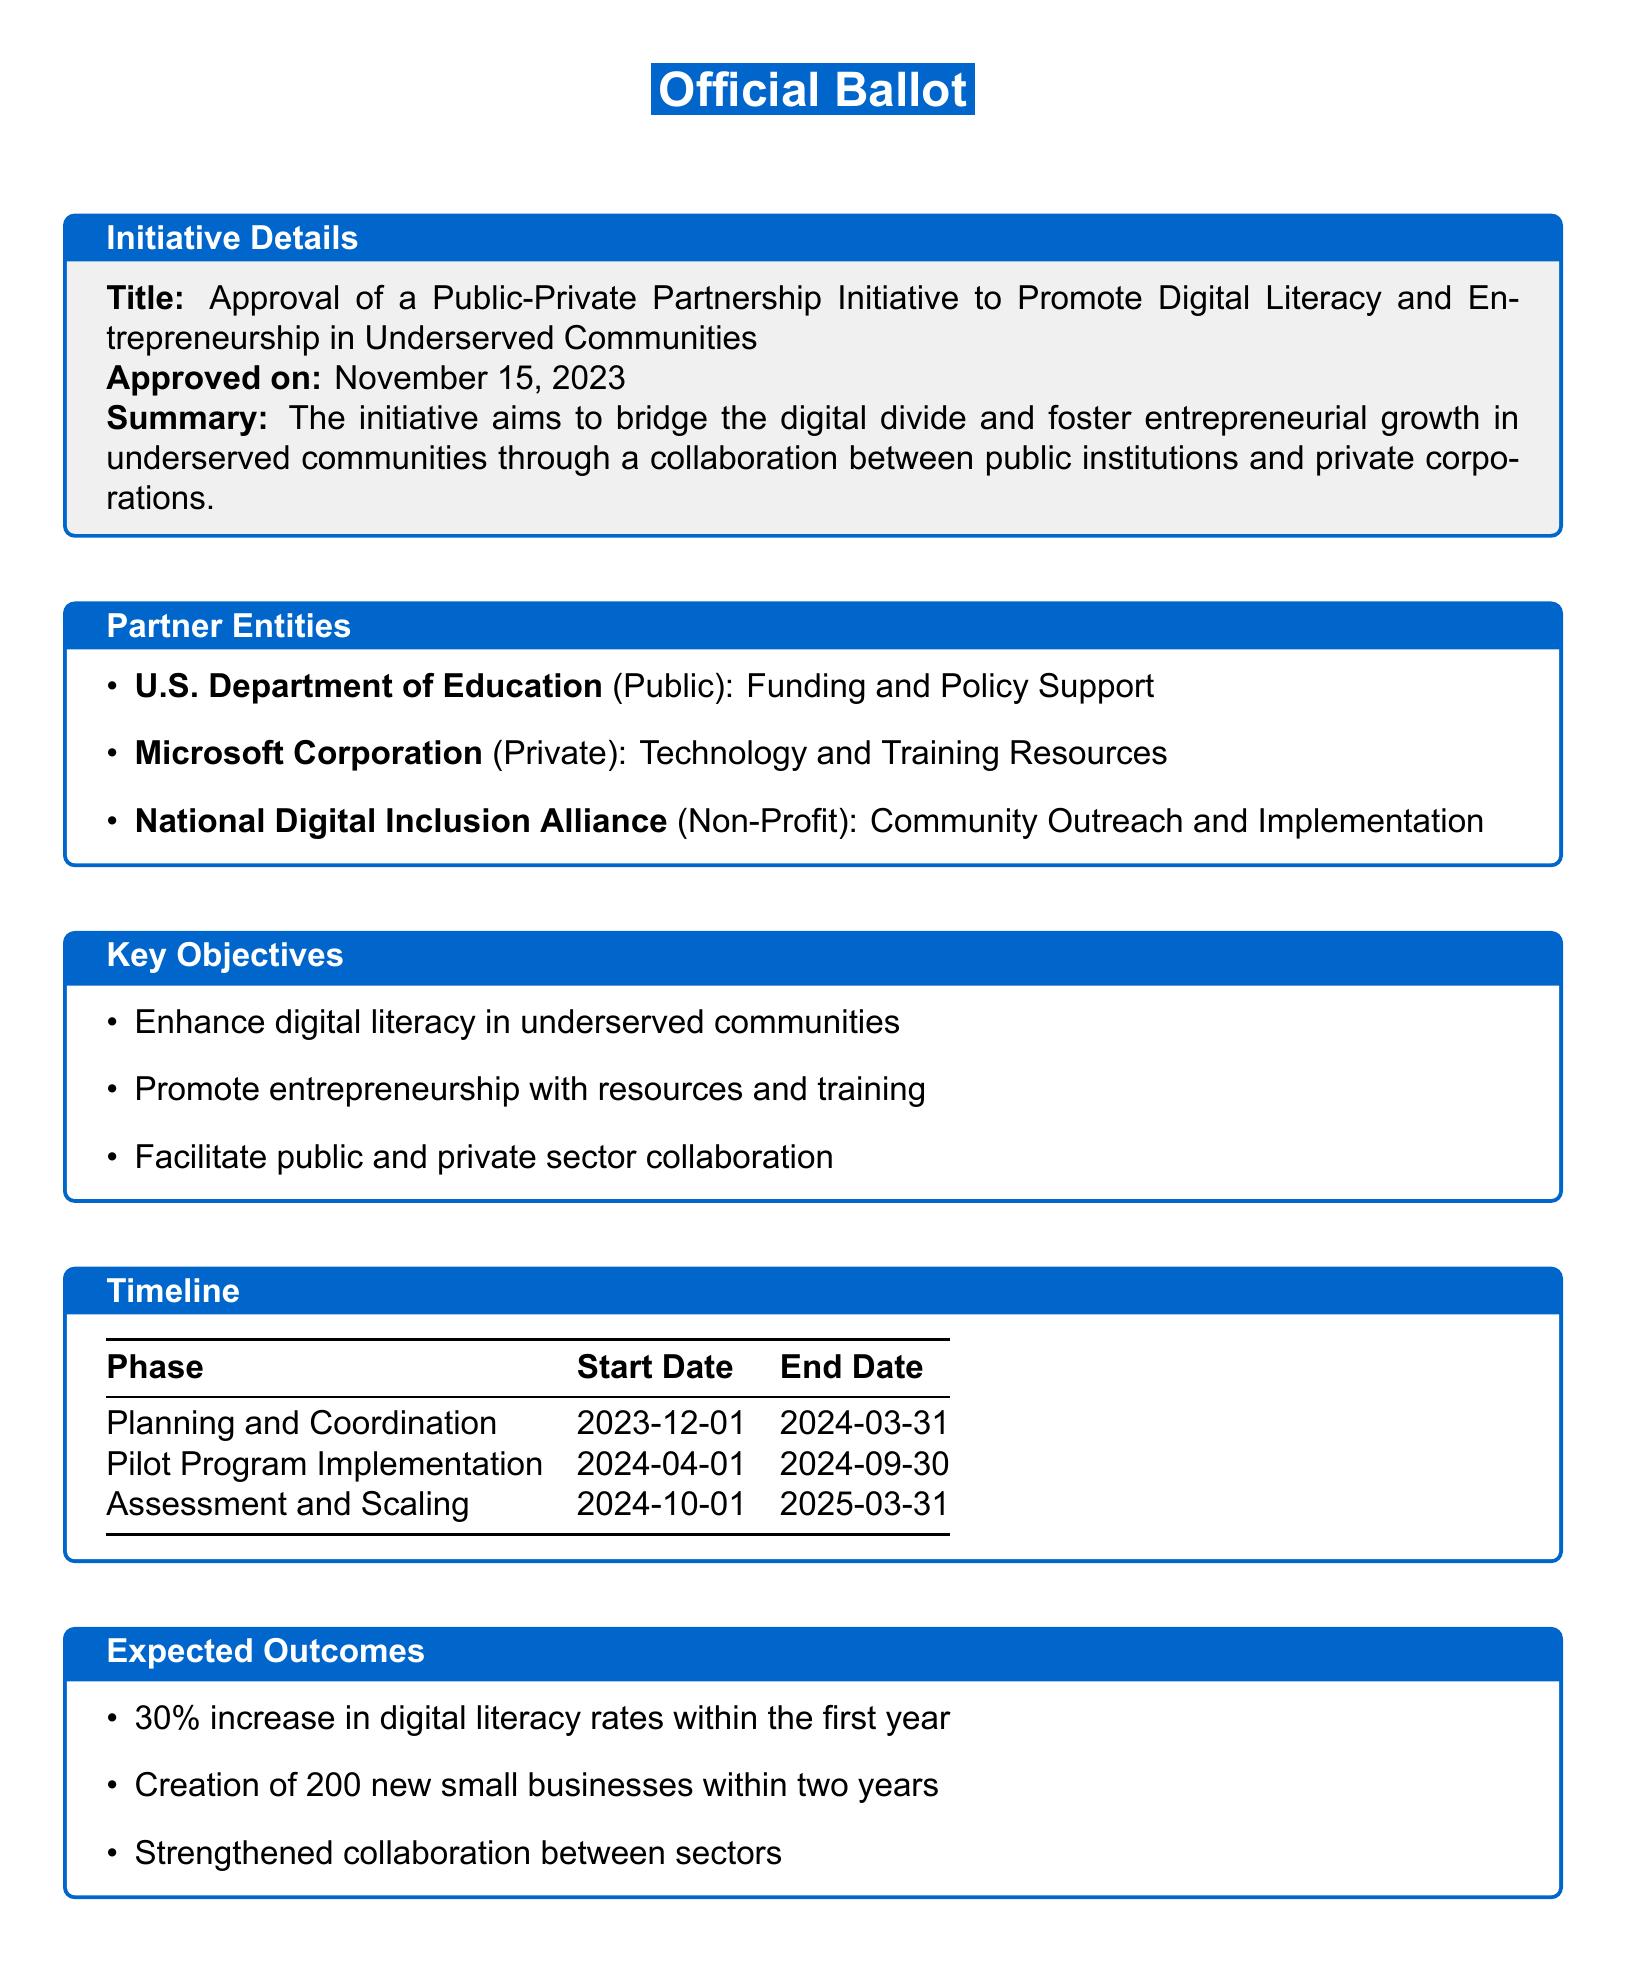What is the title of the initiative? The title of the initiative is provided at the beginning of the document.
Answer: Approval of a Public-Private Partnership Initiative to Promote Digital Literacy and Entrepreneurship in Underserved Communities When was the initiative approved? The approval date is mentioned in the initiative details section of the document.
Answer: November 15, 2023 What type of support does the U.S. Department of Education provide? The document specifies the role of the U.S. Department of Education in the partner entities section.
Answer: Funding and Policy Support What is one key objective of the initiative? The document lists key objectives in one of its sections, each highlighting the goals of the initiative.
Answer: Enhance digital literacy in underserved communities What is the end date of the Pilot Program Implementation phase? The timeline section provides start and end dates for each phase of the initiative.
Answer: 2024-09-30 How many new small businesses are expected to be created within two years? The expected outcomes outline the anticipated impact of the initiative on small businesses.
Answer: 200 What is the expected increase in digital literacy rates within the first year? The specific numerical target is given in the expected outcomes section of the document.
Answer: 30% Who is responsible for community outreach and implementation? This information can be found in the partner entities section identifying the roles of each partner.
Answer: National Digital Inclusion Alliance What type of partnership is being proposed in the initiative? The nature of the partnership is described in the title and the summary section.
Answer: Public-Private Partnership 